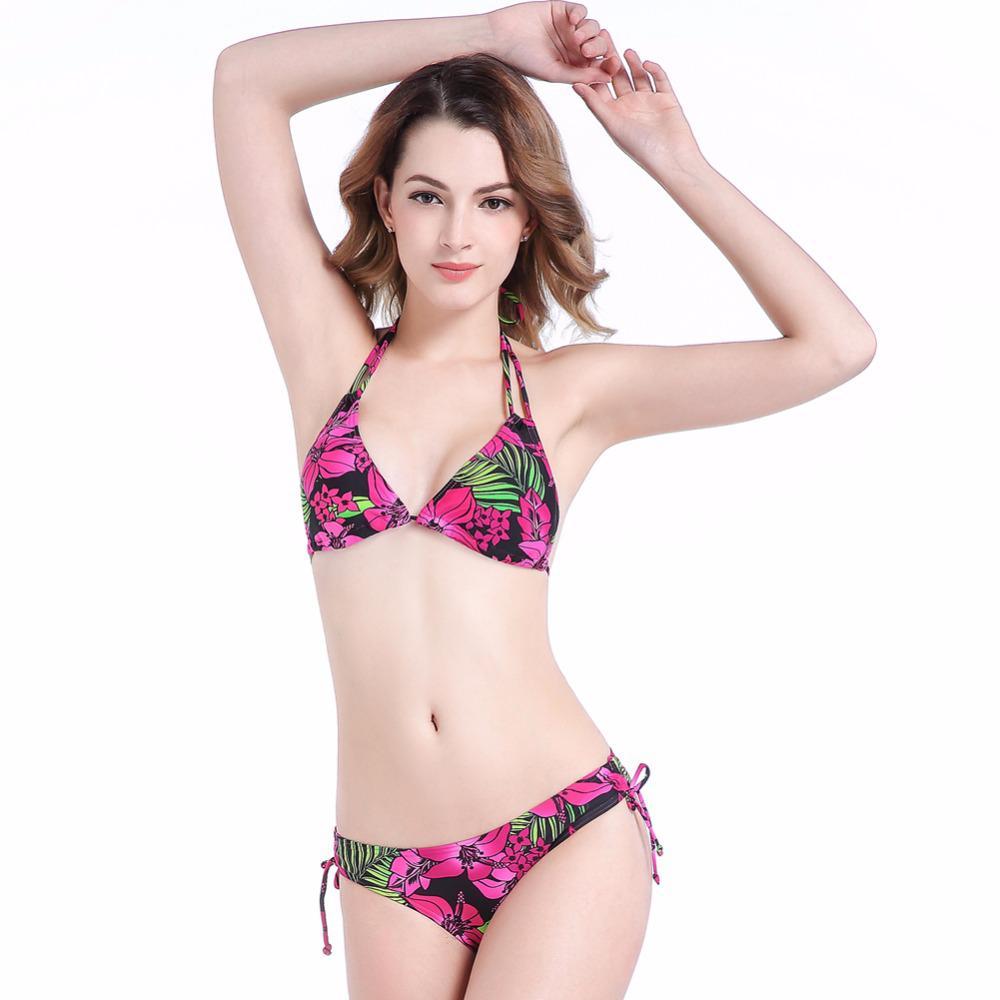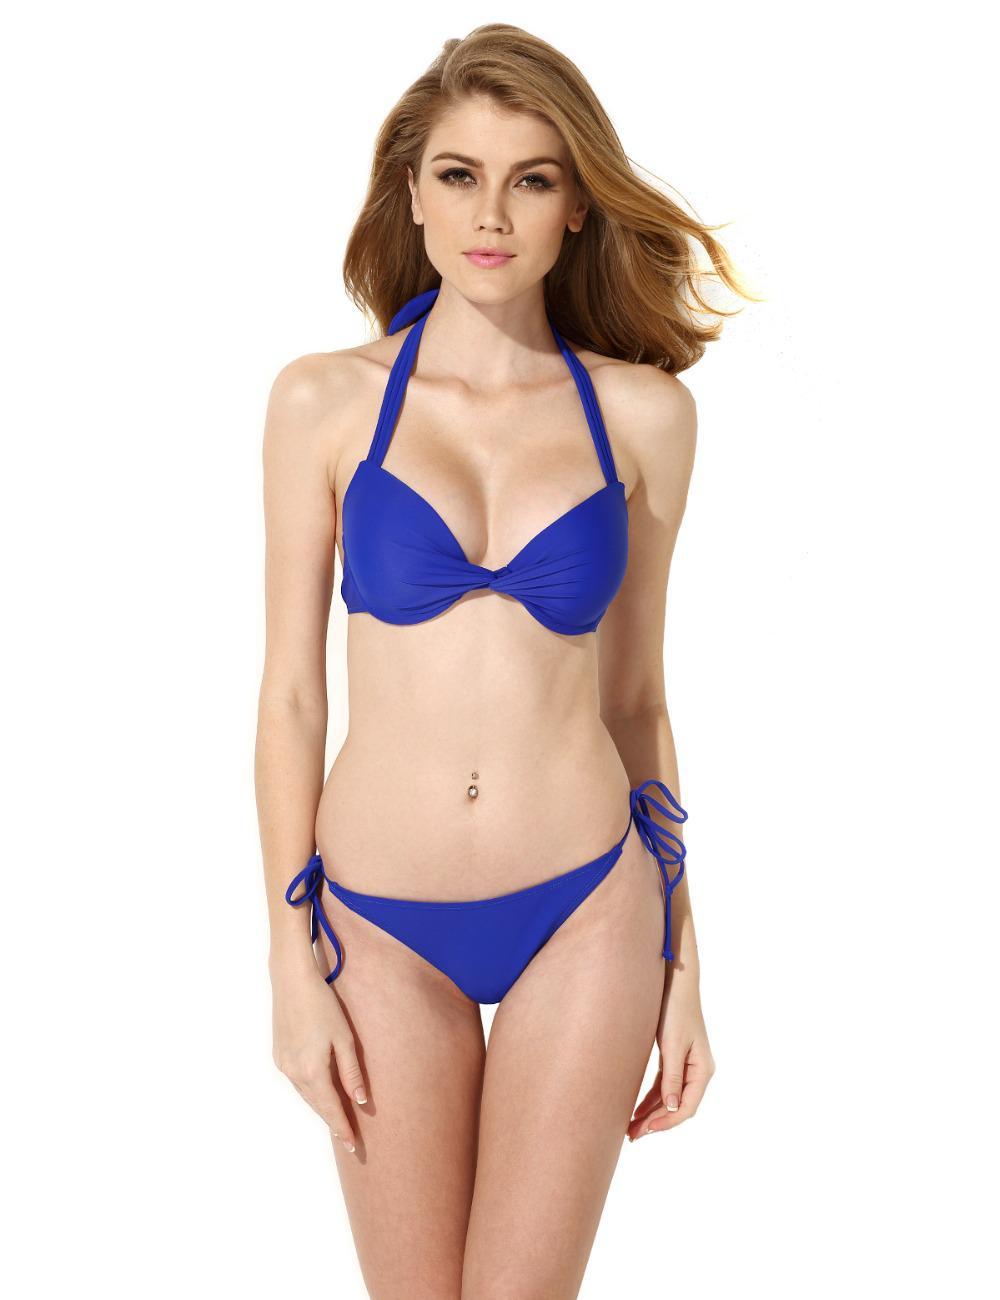The first image is the image on the left, the second image is the image on the right. Given the left and right images, does the statement "At least one of the bikini models pictured is a child." hold true? Answer yes or no. No. 